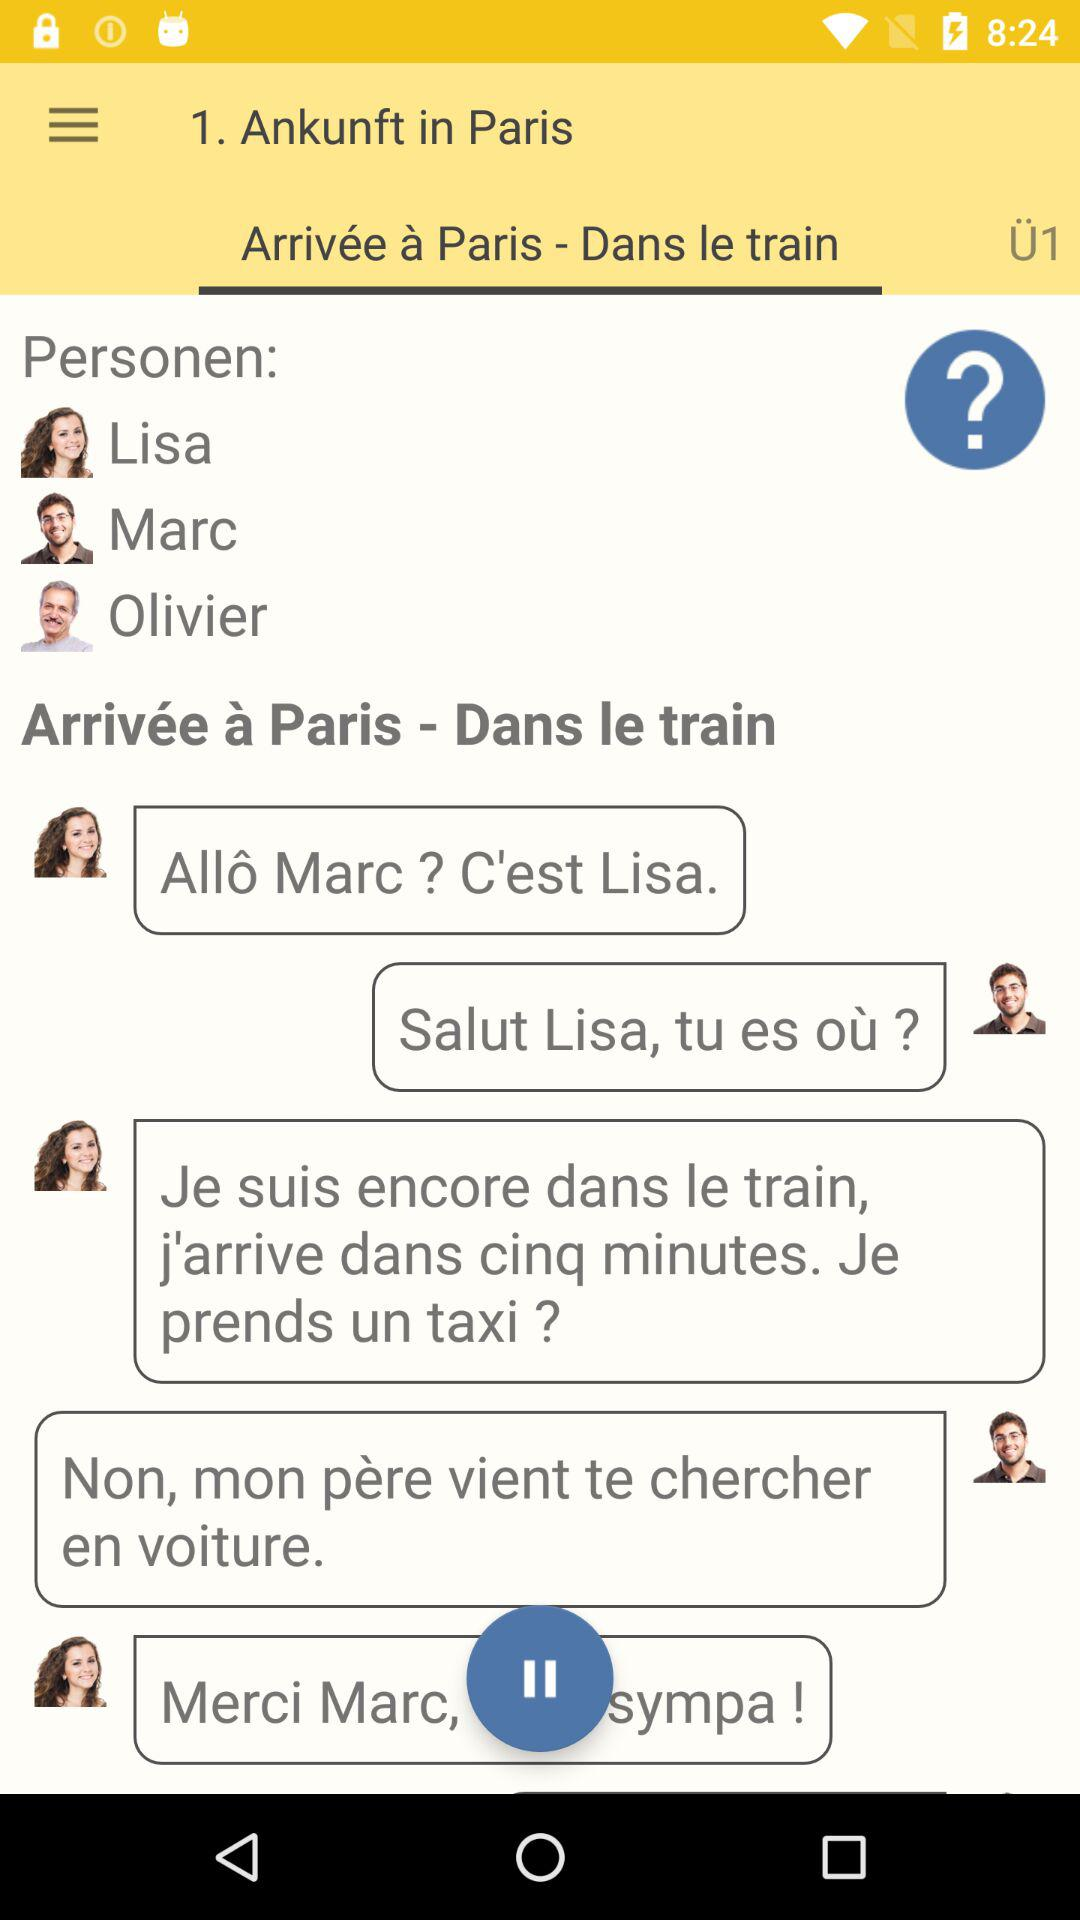How many people are in the conversation?
Answer the question using a single word or phrase. 3 